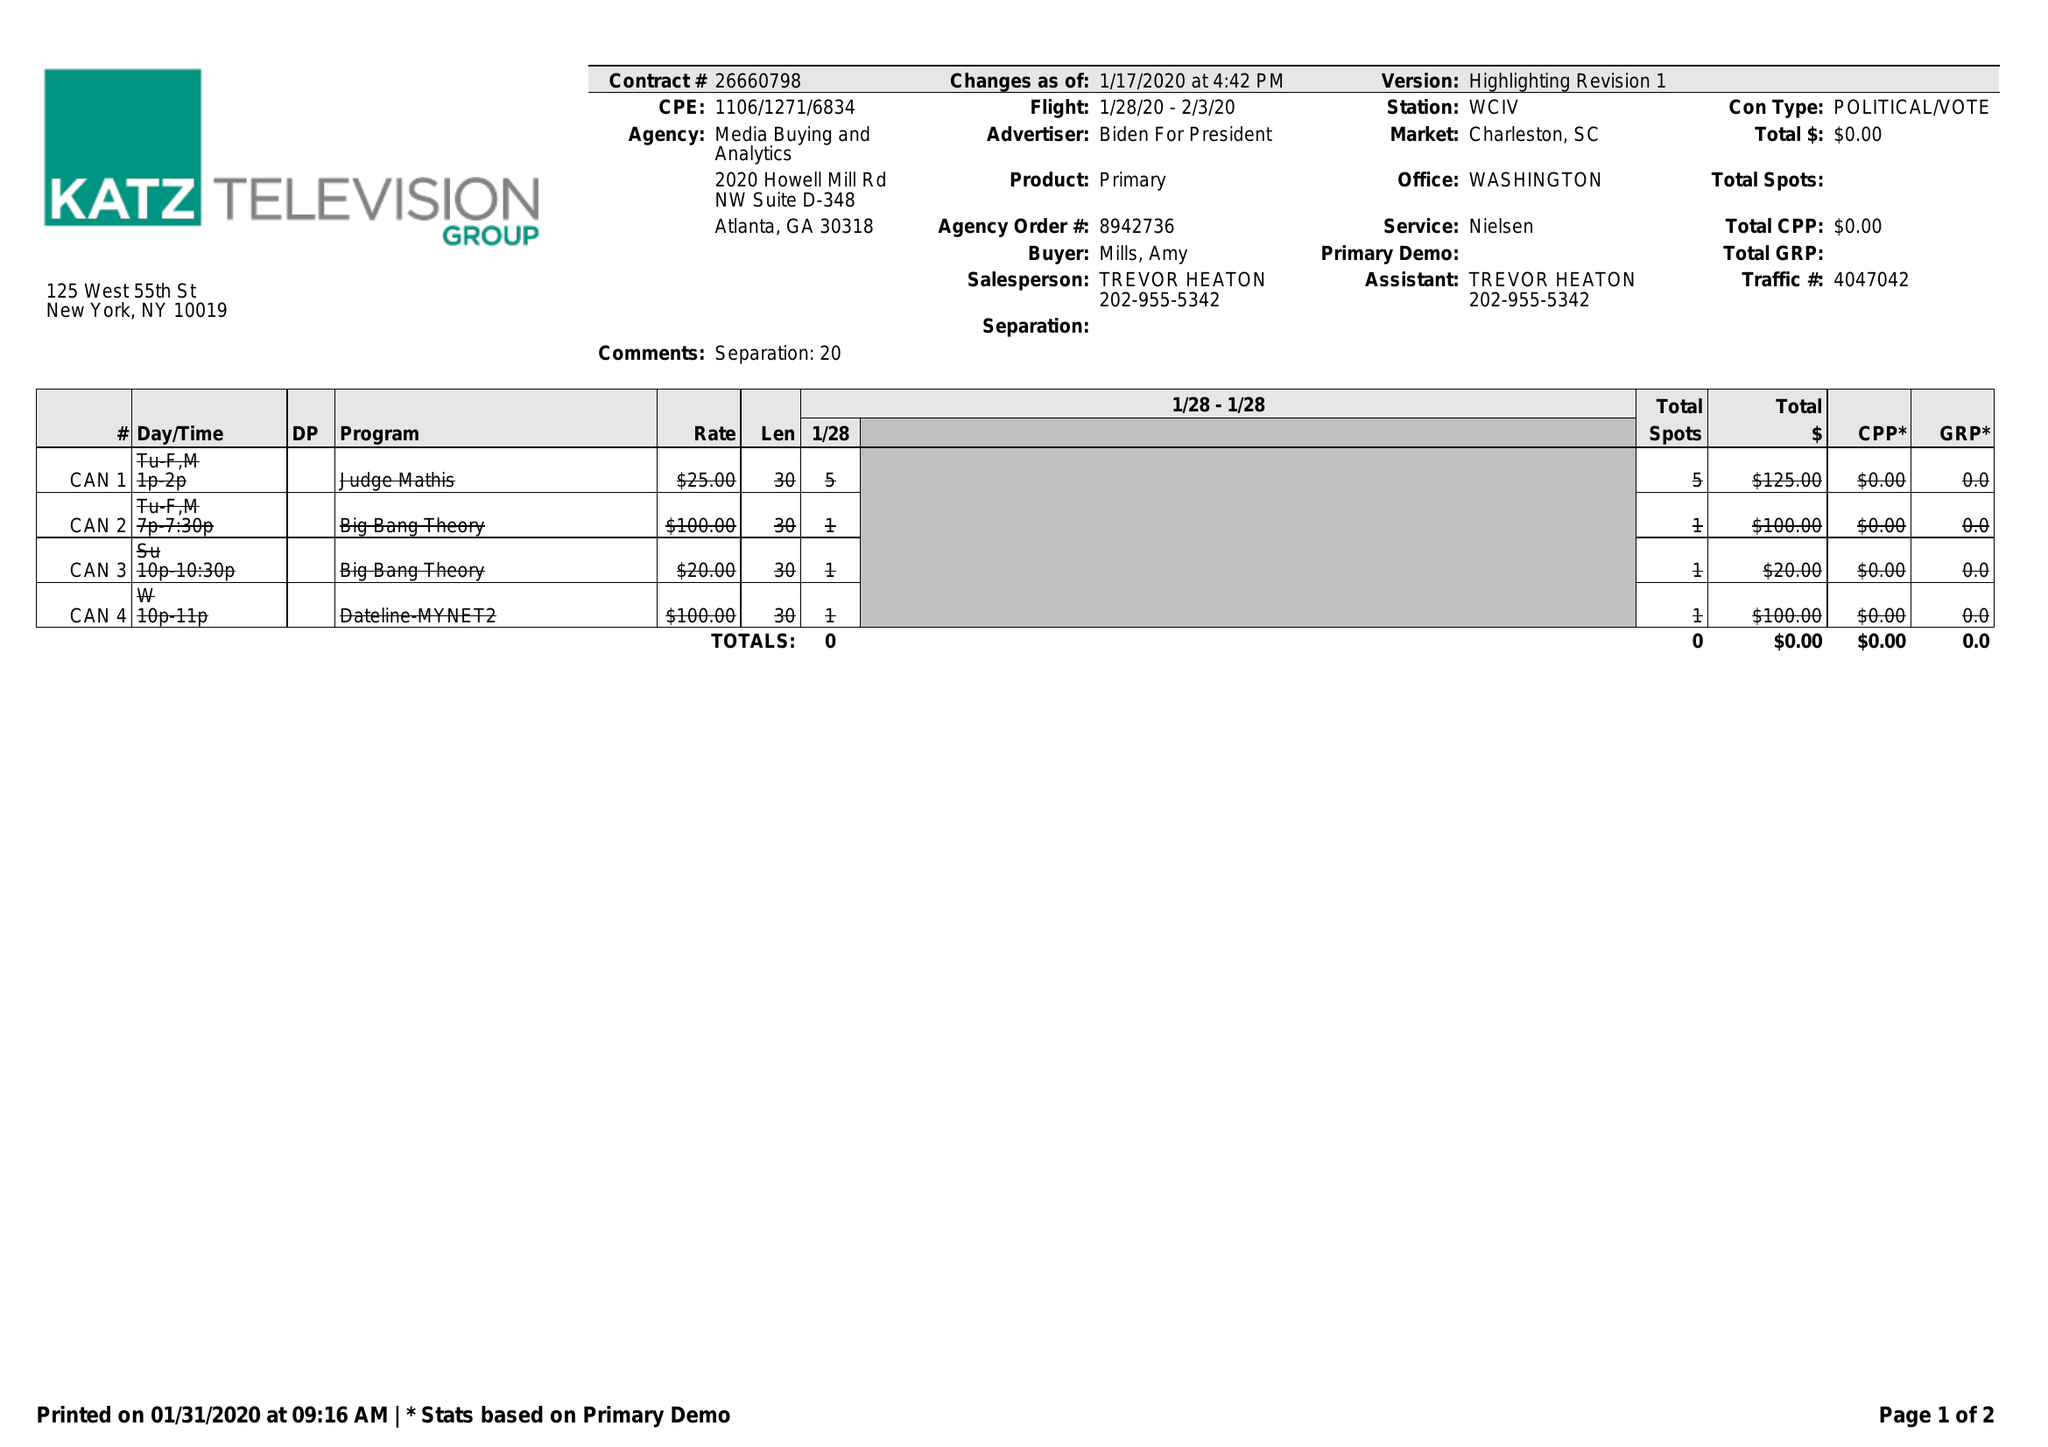What is the value for the flight_from?
Answer the question using a single word or phrase. 01/28/20 